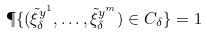Convert formula to latex. <formula><loc_0><loc_0><loc_500><loc_500>\P \{ ( \tilde { \xi } ^ { y ^ { 1 } } _ { \delta } , \dots , \tilde { \xi } ^ { y ^ { m } } _ { \delta } ) \in C _ { \delta } \} = 1</formula> 